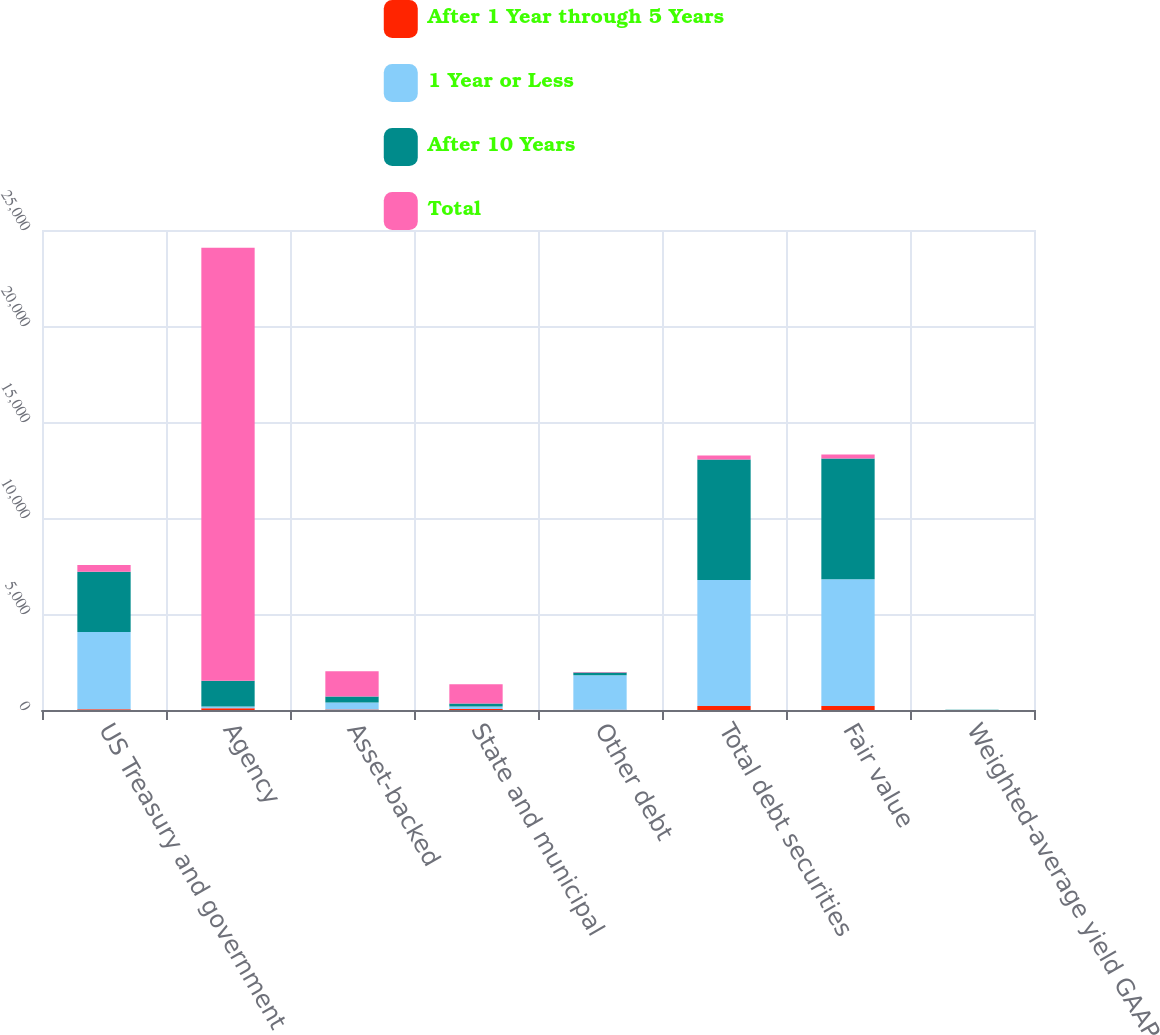Convert chart to OTSL. <chart><loc_0><loc_0><loc_500><loc_500><stacked_bar_chart><ecel><fcel>US Treasury and government<fcel>Agency<fcel>Asset-backed<fcel>State and municipal<fcel>Other debt<fcel>Total debt securities<fcel>Fair value<fcel>Weighted-average yield GAAP<nl><fcel>After 1 Year through 5 Years<fcel>33<fcel>90<fcel>26<fcel>46<fcel>10<fcel>205<fcel>207<fcel>3.47<nl><fcel>1 Year or Less<fcel>4025<fcel>90<fcel>364<fcel>131<fcel>1798<fcel>6567<fcel>6607<fcel>2.82<nl><fcel>After 10 Years<fcel>3148<fcel>1341<fcel>315<fcel>165<fcel>150<fcel>6271<fcel>6283<fcel>3.75<nl><fcel>Total<fcel>342<fcel>22555<fcel>1314<fcel>1004<fcel>26<fcel>206<fcel>206<fcel>4.65<nl></chart> 